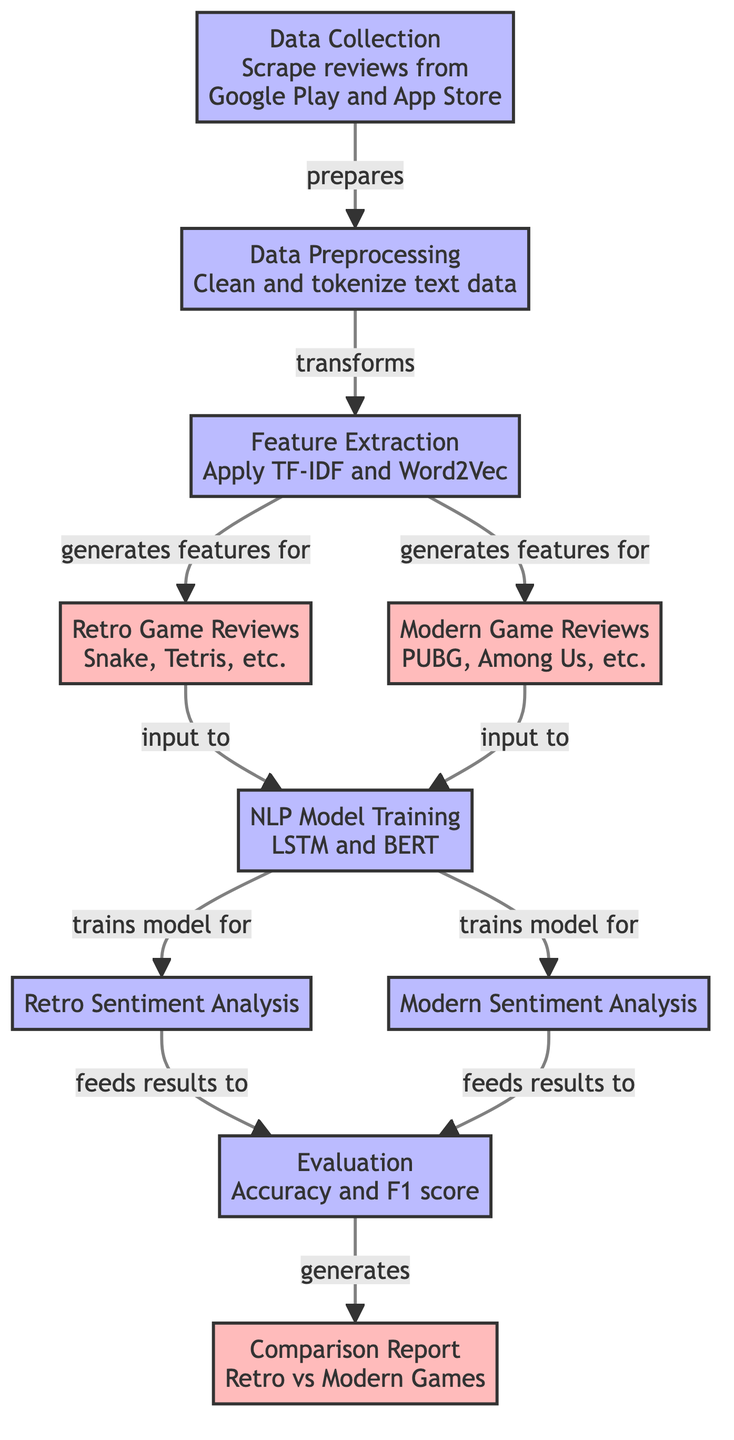What is the first step in the process? The diagram begins with 'Data Collection', which is the first step where reviews are scraped from Google Play and App Store.
Answer: Data Collection How many types of game reviews are mentioned? The diagram specifies two types of game reviews: Retro Game Reviews and Modern Game Reviews.
Answer: Two What models are used for training in the NLP Model Training step? The diagram indicates that LSTM and BERT models are employed during the NLP Model Training phase.
Answer: LSTM and BERT Which step follows Data Preprocessing? After Data Preprocessing, the flowchart shows that the next step is Feature Extraction.
Answer: Feature Extraction What is produced after the Evaluation step? The output of the Evaluation step is the Comparison Report, which compares retro and modern games.
Answer: Comparison Report Which reviews contribute to the Retro Sentiment Analysis? The Retro Game Reviews featuring titles like Snake and Tetris are the inputs for Retro Sentiment Analysis.
Answer: Retro Game Reviews How does Feature Extraction interact with the reviews? Feature Extraction interacts with both Retro and Modern Game Reviews by generating features usable in subsequent steps, specifically for model training.
Answer: Generates features for both reviews What is the primary function of the Evaluation step? The Evaluation step assesses the performance of models by calculating accuracy and F1 score.
Answer: Accuracy and F1 score What is the main distinction highlighted in the Comparison Report? The Comparison Report focuses on comparing the sentiment analysis results of Retro vs Modern Games.
Answer: Retro vs Modern Games 